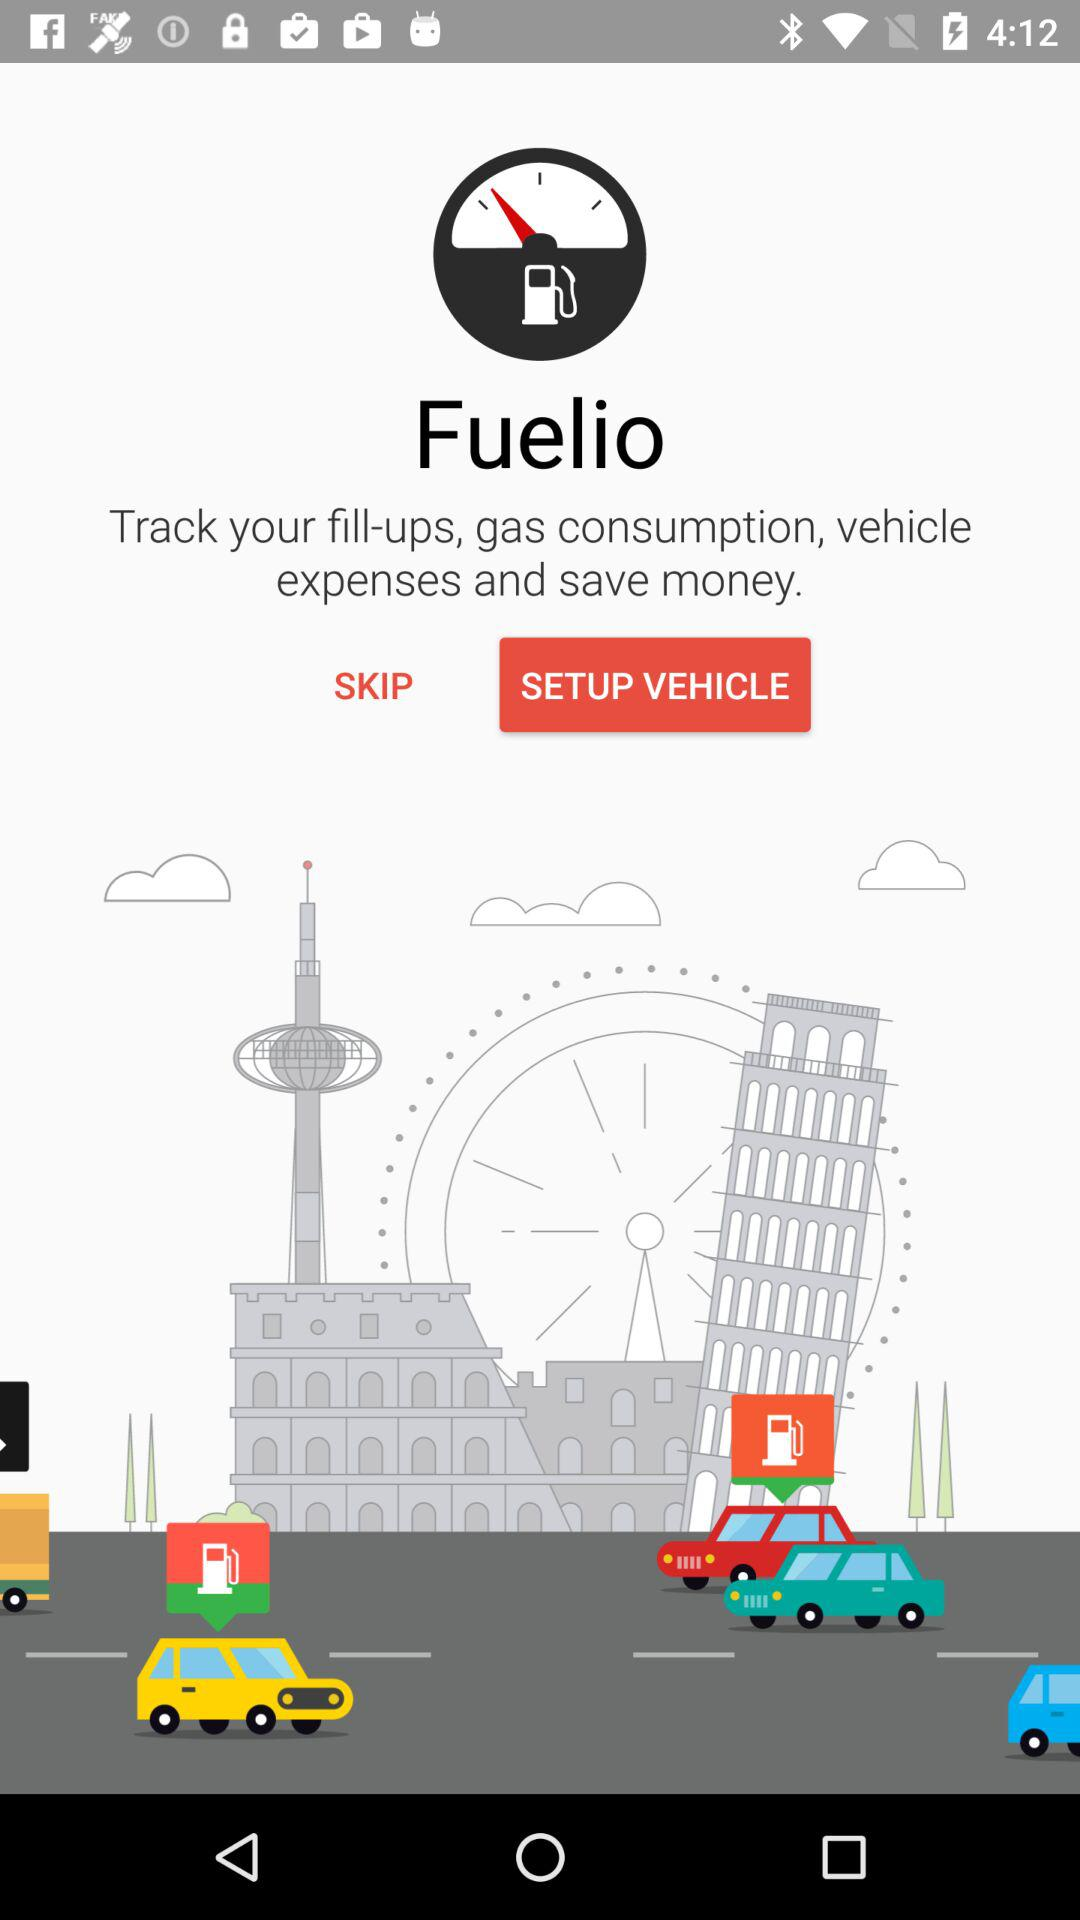How much money was spent on the last fill-up?
When the provided information is insufficient, respond with <no answer>. <no answer> 